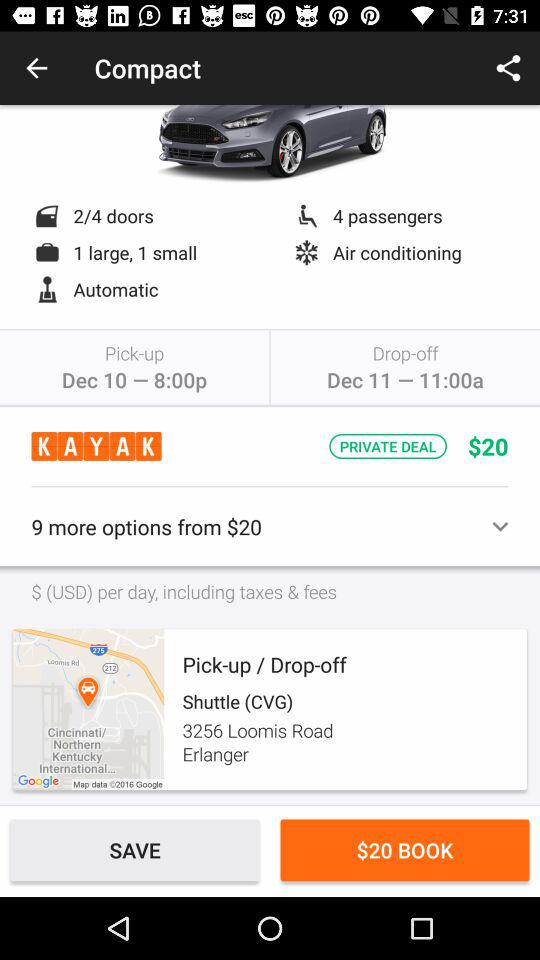Is the car manual or automatic? The car is "Automatic". 